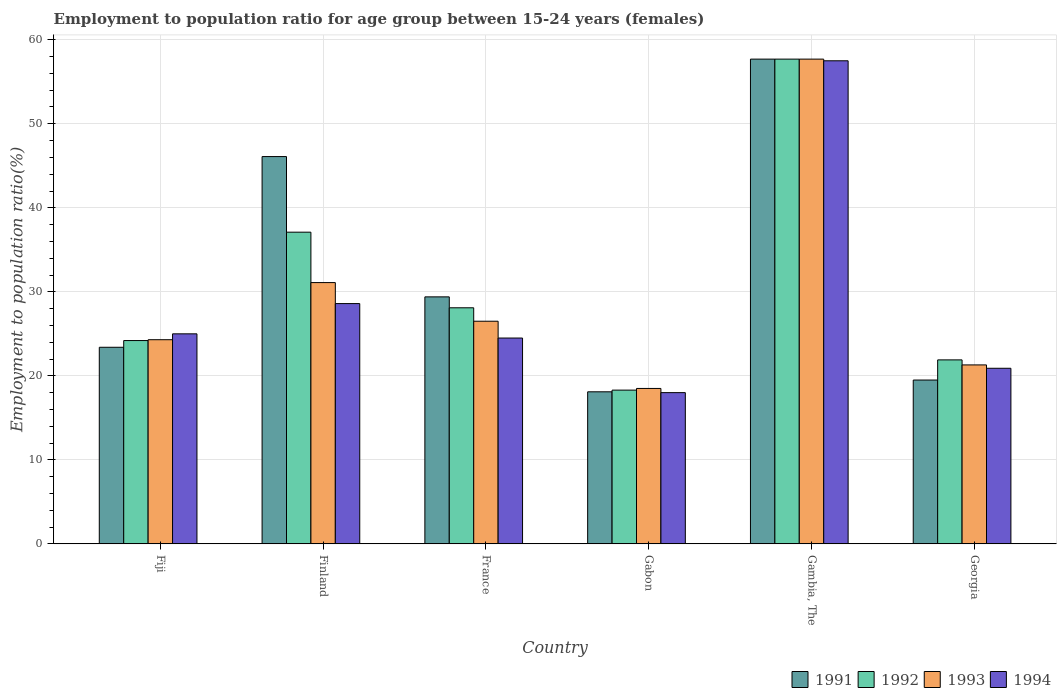How many bars are there on the 3rd tick from the left?
Provide a succinct answer. 4. How many bars are there on the 2nd tick from the right?
Your answer should be compact. 4. What is the label of the 6th group of bars from the left?
Keep it short and to the point. Georgia. In how many cases, is the number of bars for a given country not equal to the number of legend labels?
Make the answer very short. 0. Across all countries, what is the maximum employment to population ratio in 1993?
Offer a terse response. 57.7. Across all countries, what is the minimum employment to population ratio in 1992?
Offer a very short reply. 18.3. In which country was the employment to population ratio in 1992 maximum?
Your answer should be very brief. Gambia, The. In which country was the employment to population ratio in 1993 minimum?
Your response must be concise. Gabon. What is the total employment to population ratio in 1993 in the graph?
Your answer should be compact. 179.4. What is the difference between the employment to population ratio in 1993 in Fiji and that in Finland?
Your response must be concise. -6.8. What is the difference between the employment to population ratio in 1993 in Gambia, The and the employment to population ratio in 1991 in Finland?
Keep it short and to the point. 11.6. What is the average employment to population ratio in 1993 per country?
Your answer should be compact. 29.9. What is the difference between the employment to population ratio of/in 1993 and employment to population ratio of/in 1991 in Finland?
Your answer should be compact. -15. What is the ratio of the employment to population ratio in 1994 in Fiji to that in Finland?
Provide a succinct answer. 0.87. Is the difference between the employment to population ratio in 1993 in Fiji and Gabon greater than the difference between the employment to population ratio in 1991 in Fiji and Gabon?
Your response must be concise. Yes. What is the difference between the highest and the second highest employment to population ratio in 1994?
Provide a succinct answer. 28.9. What is the difference between the highest and the lowest employment to population ratio in 1992?
Offer a terse response. 39.4. In how many countries, is the employment to population ratio in 1993 greater than the average employment to population ratio in 1993 taken over all countries?
Ensure brevity in your answer.  2. Is it the case that in every country, the sum of the employment to population ratio in 1994 and employment to population ratio in 1993 is greater than the employment to population ratio in 1992?
Provide a short and direct response. Yes. How many bars are there?
Give a very brief answer. 24. Are the values on the major ticks of Y-axis written in scientific E-notation?
Provide a succinct answer. No. Does the graph contain any zero values?
Ensure brevity in your answer.  No. Where does the legend appear in the graph?
Provide a short and direct response. Bottom right. How many legend labels are there?
Ensure brevity in your answer.  4. How are the legend labels stacked?
Your answer should be compact. Horizontal. What is the title of the graph?
Give a very brief answer. Employment to population ratio for age group between 15-24 years (females). What is the label or title of the Y-axis?
Provide a short and direct response. Employment to population ratio(%). What is the Employment to population ratio(%) of 1991 in Fiji?
Your answer should be very brief. 23.4. What is the Employment to population ratio(%) of 1992 in Fiji?
Offer a very short reply. 24.2. What is the Employment to population ratio(%) of 1993 in Fiji?
Ensure brevity in your answer.  24.3. What is the Employment to population ratio(%) of 1994 in Fiji?
Give a very brief answer. 25. What is the Employment to population ratio(%) of 1991 in Finland?
Provide a short and direct response. 46.1. What is the Employment to population ratio(%) of 1992 in Finland?
Ensure brevity in your answer.  37.1. What is the Employment to population ratio(%) in 1993 in Finland?
Your response must be concise. 31.1. What is the Employment to population ratio(%) of 1994 in Finland?
Provide a short and direct response. 28.6. What is the Employment to population ratio(%) in 1991 in France?
Make the answer very short. 29.4. What is the Employment to population ratio(%) of 1992 in France?
Offer a very short reply. 28.1. What is the Employment to population ratio(%) of 1993 in France?
Offer a very short reply. 26.5. What is the Employment to population ratio(%) in 1991 in Gabon?
Offer a very short reply. 18.1. What is the Employment to population ratio(%) in 1992 in Gabon?
Offer a very short reply. 18.3. What is the Employment to population ratio(%) in 1993 in Gabon?
Ensure brevity in your answer.  18.5. What is the Employment to population ratio(%) in 1994 in Gabon?
Provide a short and direct response. 18. What is the Employment to population ratio(%) in 1991 in Gambia, The?
Your response must be concise. 57.7. What is the Employment to population ratio(%) of 1992 in Gambia, The?
Provide a succinct answer. 57.7. What is the Employment to population ratio(%) of 1993 in Gambia, The?
Provide a succinct answer. 57.7. What is the Employment to population ratio(%) in 1994 in Gambia, The?
Make the answer very short. 57.5. What is the Employment to population ratio(%) in 1992 in Georgia?
Your answer should be very brief. 21.9. What is the Employment to population ratio(%) in 1993 in Georgia?
Provide a short and direct response. 21.3. What is the Employment to population ratio(%) of 1994 in Georgia?
Offer a terse response. 20.9. Across all countries, what is the maximum Employment to population ratio(%) in 1991?
Your answer should be very brief. 57.7. Across all countries, what is the maximum Employment to population ratio(%) in 1992?
Ensure brevity in your answer.  57.7. Across all countries, what is the maximum Employment to population ratio(%) of 1993?
Offer a terse response. 57.7. Across all countries, what is the maximum Employment to population ratio(%) of 1994?
Offer a very short reply. 57.5. Across all countries, what is the minimum Employment to population ratio(%) in 1991?
Provide a short and direct response. 18.1. Across all countries, what is the minimum Employment to population ratio(%) in 1992?
Your response must be concise. 18.3. Across all countries, what is the minimum Employment to population ratio(%) in 1994?
Your answer should be compact. 18. What is the total Employment to population ratio(%) in 1991 in the graph?
Offer a very short reply. 194.2. What is the total Employment to population ratio(%) in 1992 in the graph?
Offer a very short reply. 187.3. What is the total Employment to population ratio(%) in 1993 in the graph?
Your answer should be compact. 179.4. What is the total Employment to population ratio(%) in 1994 in the graph?
Ensure brevity in your answer.  174.5. What is the difference between the Employment to population ratio(%) in 1991 in Fiji and that in Finland?
Provide a succinct answer. -22.7. What is the difference between the Employment to population ratio(%) of 1992 in Fiji and that in Finland?
Your response must be concise. -12.9. What is the difference between the Employment to population ratio(%) in 1994 in Fiji and that in Finland?
Provide a short and direct response. -3.6. What is the difference between the Employment to population ratio(%) in 1991 in Fiji and that in France?
Make the answer very short. -6. What is the difference between the Employment to population ratio(%) of 1992 in Fiji and that in France?
Offer a very short reply. -3.9. What is the difference between the Employment to population ratio(%) of 1993 in Fiji and that in France?
Make the answer very short. -2.2. What is the difference between the Employment to population ratio(%) in 1991 in Fiji and that in Gabon?
Provide a short and direct response. 5.3. What is the difference between the Employment to population ratio(%) in 1994 in Fiji and that in Gabon?
Offer a terse response. 7. What is the difference between the Employment to population ratio(%) in 1991 in Fiji and that in Gambia, The?
Offer a terse response. -34.3. What is the difference between the Employment to population ratio(%) in 1992 in Fiji and that in Gambia, The?
Ensure brevity in your answer.  -33.5. What is the difference between the Employment to population ratio(%) in 1993 in Fiji and that in Gambia, The?
Your response must be concise. -33.4. What is the difference between the Employment to population ratio(%) of 1994 in Fiji and that in Gambia, The?
Provide a short and direct response. -32.5. What is the difference between the Employment to population ratio(%) in 1994 in Finland and that in France?
Ensure brevity in your answer.  4.1. What is the difference between the Employment to population ratio(%) in 1993 in Finland and that in Gabon?
Ensure brevity in your answer.  12.6. What is the difference between the Employment to population ratio(%) in 1991 in Finland and that in Gambia, The?
Provide a succinct answer. -11.6. What is the difference between the Employment to population ratio(%) of 1992 in Finland and that in Gambia, The?
Offer a terse response. -20.6. What is the difference between the Employment to population ratio(%) in 1993 in Finland and that in Gambia, The?
Offer a terse response. -26.6. What is the difference between the Employment to population ratio(%) of 1994 in Finland and that in Gambia, The?
Ensure brevity in your answer.  -28.9. What is the difference between the Employment to population ratio(%) of 1991 in Finland and that in Georgia?
Offer a very short reply. 26.6. What is the difference between the Employment to population ratio(%) of 1992 in Finland and that in Georgia?
Your response must be concise. 15.2. What is the difference between the Employment to population ratio(%) in 1993 in Finland and that in Georgia?
Provide a succinct answer. 9.8. What is the difference between the Employment to population ratio(%) of 1992 in France and that in Gabon?
Your response must be concise. 9.8. What is the difference between the Employment to population ratio(%) in 1994 in France and that in Gabon?
Your answer should be very brief. 6.5. What is the difference between the Employment to population ratio(%) in 1991 in France and that in Gambia, The?
Offer a terse response. -28.3. What is the difference between the Employment to population ratio(%) in 1992 in France and that in Gambia, The?
Your response must be concise. -29.6. What is the difference between the Employment to population ratio(%) of 1993 in France and that in Gambia, The?
Provide a succinct answer. -31.2. What is the difference between the Employment to population ratio(%) in 1994 in France and that in Gambia, The?
Ensure brevity in your answer.  -33. What is the difference between the Employment to population ratio(%) of 1992 in France and that in Georgia?
Offer a terse response. 6.2. What is the difference between the Employment to population ratio(%) of 1994 in France and that in Georgia?
Keep it short and to the point. 3.6. What is the difference between the Employment to population ratio(%) in 1991 in Gabon and that in Gambia, The?
Your response must be concise. -39.6. What is the difference between the Employment to population ratio(%) of 1992 in Gabon and that in Gambia, The?
Ensure brevity in your answer.  -39.4. What is the difference between the Employment to population ratio(%) in 1993 in Gabon and that in Gambia, The?
Provide a short and direct response. -39.2. What is the difference between the Employment to population ratio(%) of 1994 in Gabon and that in Gambia, The?
Provide a short and direct response. -39.5. What is the difference between the Employment to population ratio(%) in 1993 in Gabon and that in Georgia?
Provide a short and direct response. -2.8. What is the difference between the Employment to population ratio(%) of 1991 in Gambia, The and that in Georgia?
Offer a terse response. 38.2. What is the difference between the Employment to population ratio(%) in 1992 in Gambia, The and that in Georgia?
Keep it short and to the point. 35.8. What is the difference between the Employment to population ratio(%) of 1993 in Gambia, The and that in Georgia?
Give a very brief answer. 36.4. What is the difference between the Employment to population ratio(%) of 1994 in Gambia, The and that in Georgia?
Provide a short and direct response. 36.6. What is the difference between the Employment to population ratio(%) in 1991 in Fiji and the Employment to population ratio(%) in 1992 in Finland?
Offer a terse response. -13.7. What is the difference between the Employment to population ratio(%) of 1991 in Fiji and the Employment to population ratio(%) of 1994 in Finland?
Your response must be concise. -5.2. What is the difference between the Employment to population ratio(%) of 1992 in Fiji and the Employment to population ratio(%) of 1993 in Finland?
Offer a very short reply. -6.9. What is the difference between the Employment to population ratio(%) in 1991 in Fiji and the Employment to population ratio(%) in 1993 in France?
Your answer should be compact. -3.1. What is the difference between the Employment to population ratio(%) of 1993 in Fiji and the Employment to population ratio(%) of 1994 in France?
Provide a succinct answer. -0.2. What is the difference between the Employment to population ratio(%) of 1991 in Fiji and the Employment to population ratio(%) of 1993 in Gabon?
Keep it short and to the point. 4.9. What is the difference between the Employment to population ratio(%) of 1991 in Fiji and the Employment to population ratio(%) of 1994 in Gabon?
Keep it short and to the point. 5.4. What is the difference between the Employment to population ratio(%) in 1992 in Fiji and the Employment to population ratio(%) in 1993 in Gabon?
Provide a short and direct response. 5.7. What is the difference between the Employment to population ratio(%) in 1991 in Fiji and the Employment to population ratio(%) in 1992 in Gambia, The?
Keep it short and to the point. -34.3. What is the difference between the Employment to population ratio(%) in 1991 in Fiji and the Employment to population ratio(%) in 1993 in Gambia, The?
Ensure brevity in your answer.  -34.3. What is the difference between the Employment to population ratio(%) of 1991 in Fiji and the Employment to population ratio(%) of 1994 in Gambia, The?
Make the answer very short. -34.1. What is the difference between the Employment to population ratio(%) of 1992 in Fiji and the Employment to population ratio(%) of 1993 in Gambia, The?
Provide a short and direct response. -33.5. What is the difference between the Employment to population ratio(%) in 1992 in Fiji and the Employment to population ratio(%) in 1994 in Gambia, The?
Offer a very short reply. -33.3. What is the difference between the Employment to population ratio(%) in 1993 in Fiji and the Employment to population ratio(%) in 1994 in Gambia, The?
Your answer should be very brief. -33.2. What is the difference between the Employment to population ratio(%) in 1991 in Fiji and the Employment to population ratio(%) in 1994 in Georgia?
Provide a short and direct response. 2.5. What is the difference between the Employment to population ratio(%) of 1992 in Fiji and the Employment to population ratio(%) of 1994 in Georgia?
Offer a very short reply. 3.3. What is the difference between the Employment to population ratio(%) of 1993 in Fiji and the Employment to population ratio(%) of 1994 in Georgia?
Keep it short and to the point. 3.4. What is the difference between the Employment to population ratio(%) of 1991 in Finland and the Employment to population ratio(%) of 1992 in France?
Give a very brief answer. 18. What is the difference between the Employment to population ratio(%) of 1991 in Finland and the Employment to population ratio(%) of 1993 in France?
Your answer should be very brief. 19.6. What is the difference between the Employment to population ratio(%) in 1991 in Finland and the Employment to population ratio(%) in 1994 in France?
Offer a terse response. 21.6. What is the difference between the Employment to population ratio(%) of 1992 in Finland and the Employment to population ratio(%) of 1994 in France?
Offer a terse response. 12.6. What is the difference between the Employment to population ratio(%) in 1991 in Finland and the Employment to population ratio(%) in 1992 in Gabon?
Ensure brevity in your answer.  27.8. What is the difference between the Employment to population ratio(%) of 1991 in Finland and the Employment to population ratio(%) of 1993 in Gabon?
Provide a short and direct response. 27.6. What is the difference between the Employment to population ratio(%) in 1991 in Finland and the Employment to population ratio(%) in 1994 in Gabon?
Offer a very short reply. 28.1. What is the difference between the Employment to population ratio(%) in 1992 in Finland and the Employment to population ratio(%) in 1993 in Gabon?
Offer a very short reply. 18.6. What is the difference between the Employment to population ratio(%) in 1992 in Finland and the Employment to population ratio(%) in 1994 in Gabon?
Provide a short and direct response. 19.1. What is the difference between the Employment to population ratio(%) of 1991 in Finland and the Employment to population ratio(%) of 1992 in Gambia, The?
Give a very brief answer. -11.6. What is the difference between the Employment to population ratio(%) in 1992 in Finland and the Employment to population ratio(%) in 1993 in Gambia, The?
Ensure brevity in your answer.  -20.6. What is the difference between the Employment to population ratio(%) in 1992 in Finland and the Employment to population ratio(%) in 1994 in Gambia, The?
Your answer should be compact. -20.4. What is the difference between the Employment to population ratio(%) in 1993 in Finland and the Employment to population ratio(%) in 1994 in Gambia, The?
Make the answer very short. -26.4. What is the difference between the Employment to population ratio(%) of 1991 in Finland and the Employment to population ratio(%) of 1992 in Georgia?
Keep it short and to the point. 24.2. What is the difference between the Employment to population ratio(%) of 1991 in Finland and the Employment to population ratio(%) of 1993 in Georgia?
Your response must be concise. 24.8. What is the difference between the Employment to population ratio(%) of 1991 in Finland and the Employment to population ratio(%) of 1994 in Georgia?
Ensure brevity in your answer.  25.2. What is the difference between the Employment to population ratio(%) of 1992 in Finland and the Employment to population ratio(%) of 1994 in Georgia?
Give a very brief answer. 16.2. What is the difference between the Employment to population ratio(%) in 1991 in France and the Employment to population ratio(%) in 1992 in Gabon?
Provide a short and direct response. 11.1. What is the difference between the Employment to population ratio(%) in 1991 in France and the Employment to population ratio(%) in 1993 in Gabon?
Provide a succinct answer. 10.9. What is the difference between the Employment to population ratio(%) of 1991 in France and the Employment to population ratio(%) of 1994 in Gabon?
Give a very brief answer. 11.4. What is the difference between the Employment to population ratio(%) of 1992 in France and the Employment to population ratio(%) of 1993 in Gabon?
Your answer should be very brief. 9.6. What is the difference between the Employment to population ratio(%) in 1991 in France and the Employment to population ratio(%) in 1992 in Gambia, The?
Give a very brief answer. -28.3. What is the difference between the Employment to population ratio(%) of 1991 in France and the Employment to population ratio(%) of 1993 in Gambia, The?
Offer a terse response. -28.3. What is the difference between the Employment to population ratio(%) in 1991 in France and the Employment to population ratio(%) in 1994 in Gambia, The?
Provide a succinct answer. -28.1. What is the difference between the Employment to population ratio(%) of 1992 in France and the Employment to population ratio(%) of 1993 in Gambia, The?
Keep it short and to the point. -29.6. What is the difference between the Employment to population ratio(%) of 1992 in France and the Employment to population ratio(%) of 1994 in Gambia, The?
Give a very brief answer. -29.4. What is the difference between the Employment to population ratio(%) of 1993 in France and the Employment to population ratio(%) of 1994 in Gambia, The?
Your response must be concise. -31. What is the difference between the Employment to population ratio(%) of 1991 in France and the Employment to population ratio(%) of 1992 in Georgia?
Your answer should be compact. 7.5. What is the difference between the Employment to population ratio(%) in 1991 in France and the Employment to population ratio(%) in 1993 in Georgia?
Your response must be concise. 8.1. What is the difference between the Employment to population ratio(%) of 1992 in France and the Employment to population ratio(%) of 1994 in Georgia?
Your answer should be compact. 7.2. What is the difference between the Employment to population ratio(%) in 1991 in Gabon and the Employment to population ratio(%) in 1992 in Gambia, The?
Your answer should be very brief. -39.6. What is the difference between the Employment to population ratio(%) of 1991 in Gabon and the Employment to population ratio(%) of 1993 in Gambia, The?
Offer a terse response. -39.6. What is the difference between the Employment to population ratio(%) of 1991 in Gabon and the Employment to population ratio(%) of 1994 in Gambia, The?
Your answer should be compact. -39.4. What is the difference between the Employment to population ratio(%) in 1992 in Gabon and the Employment to population ratio(%) in 1993 in Gambia, The?
Offer a terse response. -39.4. What is the difference between the Employment to population ratio(%) in 1992 in Gabon and the Employment to population ratio(%) in 1994 in Gambia, The?
Provide a succinct answer. -39.2. What is the difference between the Employment to population ratio(%) in 1993 in Gabon and the Employment to population ratio(%) in 1994 in Gambia, The?
Offer a terse response. -39. What is the difference between the Employment to population ratio(%) of 1991 in Gabon and the Employment to population ratio(%) of 1992 in Georgia?
Provide a short and direct response. -3.8. What is the difference between the Employment to population ratio(%) of 1991 in Gabon and the Employment to population ratio(%) of 1993 in Georgia?
Give a very brief answer. -3.2. What is the difference between the Employment to population ratio(%) in 1991 in Gabon and the Employment to population ratio(%) in 1994 in Georgia?
Make the answer very short. -2.8. What is the difference between the Employment to population ratio(%) in 1992 in Gabon and the Employment to population ratio(%) in 1993 in Georgia?
Your answer should be compact. -3. What is the difference between the Employment to population ratio(%) of 1993 in Gabon and the Employment to population ratio(%) of 1994 in Georgia?
Your answer should be compact. -2.4. What is the difference between the Employment to population ratio(%) of 1991 in Gambia, The and the Employment to population ratio(%) of 1992 in Georgia?
Your answer should be compact. 35.8. What is the difference between the Employment to population ratio(%) in 1991 in Gambia, The and the Employment to population ratio(%) in 1993 in Georgia?
Your answer should be compact. 36.4. What is the difference between the Employment to population ratio(%) in 1991 in Gambia, The and the Employment to population ratio(%) in 1994 in Georgia?
Provide a short and direct response. 36.8. What is the difference between the Employment to population ratio(%) in 1992 in Gambia, The and the Employment to population ratio(%) in 1993 in Georgia?
Provide a succinct answer. 36.4. What is the difference between the Employment to population ratio(%) of 1992 in Gambia, The and the Employment to population ratio(%) of 1994 in Georgia?
Your response must be concise. 36.8. What is the difference between the Employment to population ratio(%) of 1993 in Gambia, The and the Employment to population ratio(%) of 1994 in Georgia?
Give a very brief answer. 36.8. What is the average Employment to population ratio(%) of 1991 per country?
Your answer should be very brief. 32.37. What is the average Employment to population ratio(%) in 1992 per country?
Provide a succinct answer. 31.22. What is the average Employment to population ratio(%) in 1993 per country?
Your response must be concise. 29.9. What is the average Employment to population ratio(%) of 1994 per country?
Your answer should be very brief. 29.08. What is the difference between the Employment to population ratio(%) in 1991 and Employment to population ratio(%) in 1994 in Fiji?
Provide a succinct answer. -1.6. What is the difference between the Employment to population ratio(%) of 1992 and Employment to population ratio(%) of 1993 in Fiji?
Provide a short and direct response. -0.1. What is the difference between the Employment to population ratio(%) of 1991 and Employment to population ratio(%) of 1992 in Finland?
Offer a terse response. 9. What is the difference between the Employment to population ratio(%) of 1991 and Employment to population ratio(%) of 1994 in Finland?
Ensure brevity in your answer.  17.5. What is the difference between the Employment to population ratio(%) in 1993 and Employment to population ratio(%) in 1994 in Finland?
Ensure brevity in your answer.  2.5. What is the difference between the Employment to population ratio(%) in 1991 and Employment to population ratio(%) in 1994 in France?
Make the answer very short. 4.9. What is the difference between the Employment to population ratio(%) of 1991 and Employment to population ratio(%) of 1993 in Gabon?
Keep it short and to the point. -0.4. What is the difference between the Employment to population ratio(%) of 1993 and Employment to population ratio(%) of 1994 in Gabon?
Your response must be concise. 0.5. What is the difference between the Employment to population ratio(%) of 1991 and Employment to population ratio(%) of 1994 in Gambia, The?
Offer a very short reply. 0.2. What is the difference between the Employment to population ratio(%) in 1992 and Employment to population ratio(%) in 1993 in Gambia, The?
Your answer should be compact. 0. What is the difference between the Employment to population ratio(%) in 1992 and Employment to population ratio(%) in 1994 in Gambia, The?
Your answer should be compact. 0.2. What is the difference between the Employment to population ratio(%) in 1993 and Employment to population ratio(%) in 1994 in Gambia, The?
Your answer should be compact. 0.2. What is the difference between the Employment to population ratio(%) in 1991 and Employment to population ratio(%) in 1992 in Georgia?
Your response must be concise. -2.4. What is the difference between the Employment to population ratio(%) in 1991 and Employment to population ratio(%) in 1993 in Georgia?
Keep it short and to the point. -1.8. What is the difference between the Employment to population ratio(%) of 1993 and Employment to population ratio(%) of 1994 in Georgia?
Your response must be concise. 0.4. What is the ratio of the Employment to population ratio(%) in 1991 in Fiji to that in Finland?
Make the answer very short. 0.51. What is the ratio of the Employment to population ratio(%) of 1992 in Fiji to that in Finland?
Your response must be concise. 0.65. What is the ratio of the Employment to population ratio(%) of 1993 in Fiji to that in Finland?
Offer a very short reply. 0.78. What is the ratio of the Employment to population ratio(%) in 1994 in Fiji to that in Finland?
Give a very brief answer. 0.87. What is the ratio of the Employment to population ratio(%) of 1991 in Fiji to that in France?
Your response must be concise. 0.8. What is the ratio of the Employment to population ratio(%) in 1992 in Fiji to that in France?
Offer a very short reply. 0.86. What is the ratio of the Employment to population ratio(%) of 1993 in Fiji to that in France?
Offer a very short reply. 0.92. What is the ratio of the Employment to population ratio(%) of 1994 in Fiji to that in France?
Keep it short and to the point. 1.02. What is the ratio of the Employment to population ratio(%) of 1991 in Fiji to that in Gabon?
Ensure brevity in your answer.  1.29. What is the ratio of the Employment to population ratio(%) of 1992 in Fiji to that in Gabon?
Offer a terse response. 1.32. What is the ratio of the Employment to population ratio(%) of 1993 in Fiji to that in Gabon?
Make the answer very short. 1.31. What is the ratio of the Employment to population ratio(%) in 1994 in Fiji to that in Gabon?
Ensure brevity in your answer.  1.39. What is the ratio of the Employment to population ratio(%) in 1991 in Fiji to that in Gambia, The?
Your answer should be compact. 0.41. What is the ratio of the Employment to population ratio(%) in 1992 in Fiji to that in Gambia, The?
Keep it short and to the point. 0.42. What is the ratio of the Employment to population ratio(%) of 1993 in Fiji to that in Gambia, The?
Provide a succinct answer. 0.42. What is the ratio of the Employment to population ratio(%) of 1994 in Fiji to that in Gambia, The?
Offer a terse response. 0.43. What is the ratio of the Employment to population ratio(%) of 1992 in Fiji to that in Georgia?
Offer a very short reply. 1.1. What is the ratio of the Employment to population ratio(%) in 1993 in Fiji to that in Georgia?
Offer a terse response. 1.14. What is the ratio of the Employment to population ratio(%) of 1994 in Fiji to that in Georgia?
Provide a succinct answer. 1.2. What is the ratio of the Employment to population ratio(%) of 1991 in Finland to that in France?
Your response must be concise. 1.57. What is the ratio of the Employment to population ratio(%) in 1992 in Finland to that in France?
Give a very brief answer. 1.32. What is the ratio of the Employment to population ratio(%) of 1993 in Finland to that in France?
Give a very brief answer. 1.17. What is the ratio of the Employment to population ratio(%) of 1994 in Finland to that in France?
Keep it short and to the point. 1.17. What is the ratio of the Employment to population ratio(%) in 1991 in Finland to that in Gabon?
Offer a terse response. 2.55. What is the ratio of the Employment to population ratio(%) in 1992 in Finland to that in Gabon?
Your response must be concise. 2.03. What is the ratio of the Employment to population ratio(%) of 1993 in Finland to that in Gabon?
Provide a succinct answer. 1.68. What is the ratio of the Employment to population ratio(%) in 1994 in Finland to that in Gabon?
Your answer should be very brief. 1.59. What is the ratio of the Employment to population ratio(%) of 1991 in Finland to that in Gambia, The?
Make the answer very short. 0.8. What is the ratio of the Employment to population ratio(%) of 1992 in Finland to that in Gambia, The?
Keep it short and to the point. 0.64. What is the ratio of the Employment to population ratio(%) of 1993 in Finland to that in Gambia, The?
Ensure brevity in your answer.  0.54. What is the ratio of the Employment to population ratio(%) of 1994 in Finland to that in Gambia, The?
Offer a very short reply. 0.5. What is the ratio of the Employment to population ratio(%) of 1991 in Finland to that in Georgia?
Give a very brief answer. 2.36. What is the ratio of the Employment to population ratio(%) of 1992 in Finland to that in Georgia?
Offer a terse response. 1.69. What is the ratio of the Employment to population ratio(%) of 1993 in Finland to that in Georgia?
Give a very brief answer. 1.46. What is the ratio of the Employment to population ratio(%) in 1994 in Finland to that in Georgia?
Keep it short and to the point. 1.37. What is the ratio of the Employment to population ratio(%) of 1991 in France to that in Gabon?
Make the answer very short. 1.62. What is the ratio of the Employment to population ratio(%) in 1992 in France to that in Gabon?
Ensure brevity in your answer.  1.54. What is the ratio of the Employment to population ratio(%) of 1993 in France to that in Gabon?
Provide a short and direct response. 1.43. What is the ratio of the Employment to population ratio(%) of 1994 in France to that in Gabon?
Provide a short and direct response. 1.36. What is the ratio of the Employment to population ratio(%) in 1991 in France to that in Gambia, The?
Give a very brief answer. 0.51. What is the ratio of the Employment to population ratio(%) in 1992 in France to that in Gambia, The?
Give a very brief answer. 0.49. What is the ratio of the Employment to population ratio(%) in 1993 in France to that in Gambia, The?
Offer a very short reply. 0.46. What is the ratio of the Employment to population ratio(%) of 1994 in France to that in Gambia, The?
Provide a short and direct response. 0.43. What is the ratio of the Employment to population ratio(%) of 1991 in France to that in Georgia?
Make the answer very short. 1.51. What is the ratio of the Employment to population ratio(%) in 1992 in France to that in Georgia?
Provide a short and direct response. 1.28. What is the ratio of the Employment to population ratio(%) in 1993 in France to that in Georgia?
Offer a terse response. 1.24. What is the ratio of the Employment to population ratio(%) of 1994 in France to that in Georgia?
Give a very brief answer. 1.17. What is the ratio of the Employment to population ratio(%) in 1991 in Gabon to that in Gambia, The?
Your answer should be very brief. 0.31. What is the ratio of the Employment to population ratio(%) in 1992 in Gabon to that in Gambia, The?
Ensure brevity in your answer.  0.32. What is the ratio of the Employment to population ratio(%) in 1993 in Gabon to that in Gambia, The?
Your answer should be very brief. 0.32. What is the ratio of the Employment to population ratio(%) in 1994 in Gabon to that in Gambia, The?
Provide a succinct answer. 0.31. What is the ratio of the Employment to population ratio(%) in 1991 in Gabon to that in Georgia?
Provide a short and direct response. 0.93. What is the ratio of the Employment to population ratio(%) of 1992 in Gabon to that in Georgia?
Keep it short and to the point. 0.84. What is the ratio of the Employment to population ratio(%) of 1993 in Gabon to that in Georgia?
Offer a terse response. 0.87. What is the ratio of the Employment to population ratio(%) in 1994 in Gabon to that in Georgia?
Your response must be concise. 0.86. What is the ratio of the Employment to population ratio(%) of 1991 in Gambia, The to that in Georgia?
Provide a succinct answer. 2.96. What is the ratio of the Employment to population ratio(%) in 1992 in Gambia, The to that in Georgia?
Ensure brevity in your answer.  2.63. What is the ratio of the Employment to population ratio(%) in 1993 in Gambia, The to that in Georgia?
Make the answer very short. 2.71. What is the ratio of the Employment to population ratio(%) in 1994 in Gambia, The to that in Georgia?
Your answer should be compact. 2.75. What is the difference between the highest and the second highest Employment to population ratio(%) of 1992?
Keep it short and to the point. 20.6. What is the difference between the highest and the second highest Employment to population ratio(%) of 1993?
Offer a very short reply. 26.6. What is the difference between the highest and the second highest Employment to population ratio(%) in 1994?
Provide a short and direct response. 28.9. What is the difference between the highest and the lowest Employment to population ratio(%) in 1991?
Give a very brief answer. 39.6. What is the difference between the highest and the lowest Employment to population ratio(%) in 1992?
Make the answer very short. 39.4. What is the difference between the highest and the lowest Employment to population ratio(%) in 1993?
Your response must be concise. 39.2. What is the difference between the highest and the lowest Employment to population ratio(%) of 1994?
Your answer should be compact. 39.5. 